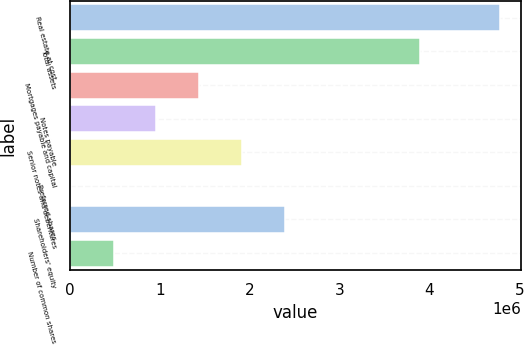<chart> <loc_0><loc_0><loc_500><loc_500><bar_chart><fcel>Real estate at cost<fcel>Total assets<fcel>Mortgages payable and capital<fcel>Notes payable<fcel>Senior notes and debentures<fcel>Preferred shares<fcel>Shareholders' equity<fcel>Number of common shares<nl><fcel>4.77967e+06<fcel>3.89856e+06<fcel>1.4409e+06<fcel>963932<fcel>1.91787e+06<fcel>9997<fcel>2.39484e+06<fcel>486965<nl></chart> 